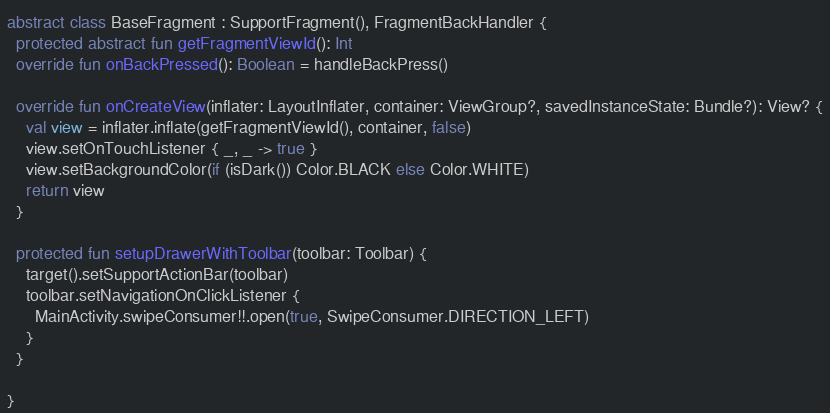<code> <loc_0><loc_0><loc_500><loc_500><_Kotlin_>
abstract class BaseFragment : SupportFragment(), FragmentBackHandler {
  protected abstract fun getFragmentViewId(): Int
  override fun onBackPressed(): Boolean = handleBackPress()

  override fun onCreateView(inflater: LayoutInflater, container: ViewGroup?, savedInstanceState: Bundle?): View? {
    val view = inflater.inflate(getFragmentViewId(), container, false)
    view.setOnTouchListener { _, _ -> true }
    view.setBackgroundColor(if (isDark()) Color.BLACK else Color.WHITE)
    return view
  }

  protected fun setupDrawerWithToolbar(toolbar: Toolbar) {
    target().setSupportActionBar(toolbar)
    toolbar.setNavigationOnClickListener {
      MainActivity.swipeConsumer!!.open(true, SwipeConsumer.DIRECTION_LEFT)
    }
  }

}
</code> 